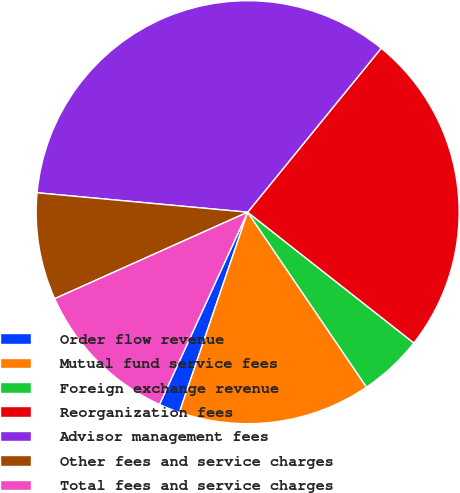Convert chart. <chart><loc_0><loc_0><loc_500><loc_500><pie_chart><fcel>Order flow revenue<fcel>Mutual fund service fees<fcel>Foreign exchange revenue<fcel>Reorganization fees<fcel>Advisor management fees<fcel>Other fees and service charges<fcel>Total fees and service charges<nl><fcel>1.61%<fcel>14.73%<fcel>4.89%<fcel>24.73%<fcel>34.41%<fcel>8.17%<fcel>11.45%<nl></chart> 